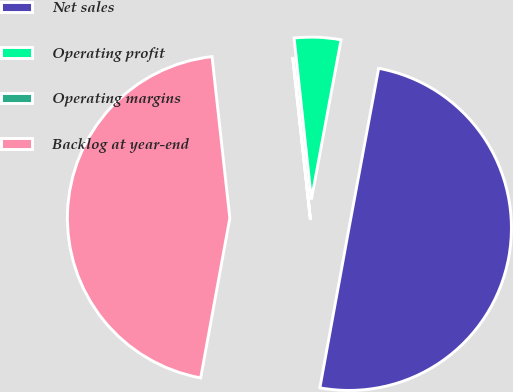<chart> <loc_0><loc_0><loc_500><loc_500><pie_chart><fcel>Net sales<fcel>Operating profit<fcel>Operating margins<fcel>Backlog at year-end<nl><fcel>49.95%<fcel>4.62%<fcel>0.05%<fcel>45.38%<nl></chart> 